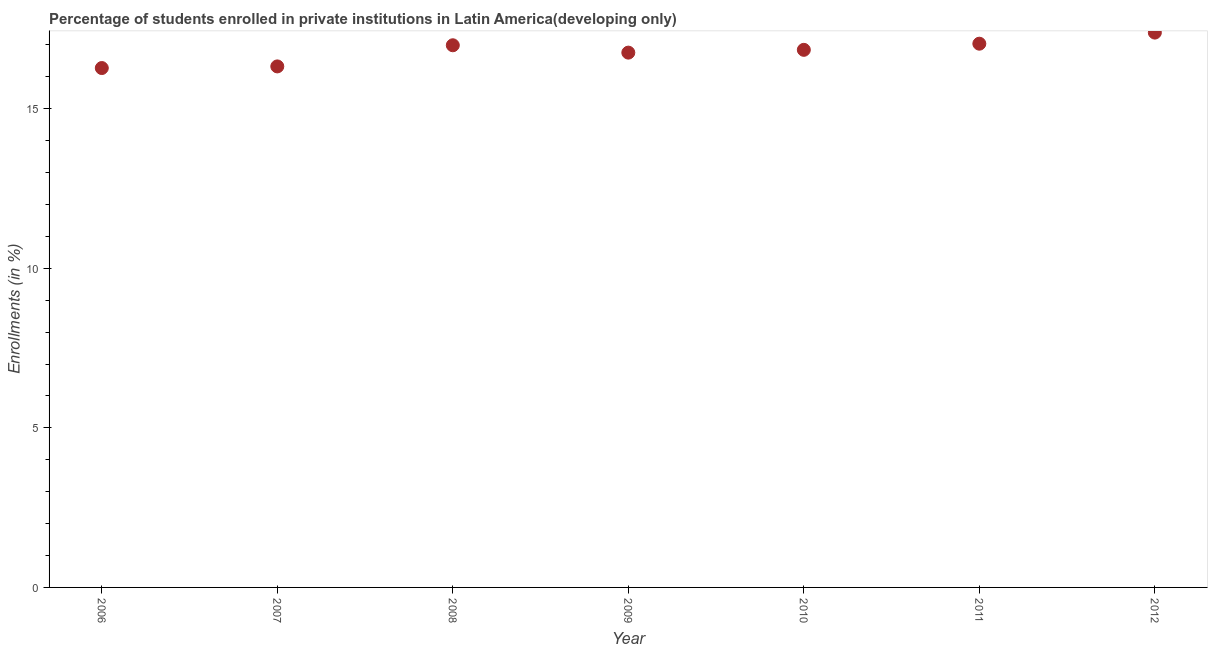What is the enrollments in private institutions in 2006?
Your response must be concise. 16.27. Across all years, what is the maximum enrollments in private institutions?
Your answer should be compact. 17.38. Across all years, what is the minimum enrollments in private institutions?
Offer a very short reply. 16.27. In which year was the enrollments in private institutions maximum?
Give a very brief answer. 2012. In which year was the enrollments in private institutions minimum?
Your response must be concise. 2006. What is the sum of the enrollments in private institutions?
Offer a very short reply. 117.6. What is the difference between the enrollments in private institutions in 2007 and 2008?
Make the answer very short. -0.66. What is the average enrollments in private institutions per year?
Provide a succinct answer. 16.8. What is the median enrollments in private institutions?
Provide a succinct answer. 16.84. In how many years, is the enrollments in private institutions greater than 12 %?
Your answer should be compact. 7. Do a majority of the years between 2010 and 2008 (inclusive) have enrollments in private institutions greater than 14 %?
Make the answer very short. No. What is the ratio of the enrollments in private institutions in 2009 to that in 2010?
Ensure brevity in your answer.  0.99. Is the difference between the enrollments in private institutions in 2008 and 2011 greater than the difference between any two years?
Your answer should be compact. No. What is the difference between the highest and the second highest enrollments in private institutions?
Your answer should be compact. 0.35. What is the difference between the highest and the lowest enrollments in private institutions?
Provide a succinct answer. 1.11. In how many years, is the enrollments in private institutions greater than the average enrollments in private institutions taken over all years?
Your answer should be very brief. 4. How many dotlines are there?
Ensure brevity in your answer.  1. Are the values on the major ticks of Y-axis written in scientific E-notation?
Keep it short and to the point. No. Does the graph contain any zero values?
Provide a succinct answer. No. What is the title of the graph?
Your answer should be very brief. Percentage of students enrolled in private institutions in Latin America(developing only). What is the label or title of the X-axis?
Ensure brevity in your answer.  Year. What is the label or title of the Y-axis?
Provide a succinct answer. Enrollments (in %). What is the Enrollments (in %) in 2006?
Your answer should be very brief. 16.27. What is the Enrollments (in %) in 2007?
Your answer should be very brief. 16.32. What is the Enrollments (in %) in 2008?
Your answer should be very brief. 16.99. What is the Enrollments (in %) in 2009?
Provide a succinct answer. 16.76. What is the Enrollments (in %) in 2010?
Offer a terse response. 16.84. What is the Enrollments (in %) in 2011?
Keep it short and to the point. 17.04. What is the Enrollments (in %) in 2012?
Keep it short and to the point. 17.38. What is the difference between the Enrollments (in %) in 2006 and 2007?
Keep it short and to the point. -0.05. What is the difference between the Enrollments (in %) in 2006 and 2008?
Offer a very short reply. -0.71. What is the difference between the Enrollments (in %) in 2006 and 2009?
Your answer should be compact. -0.48. What is the difference between the Enrollments (in %) in 2006 and 2010?
Make the answer very short. -0.57. What is the difference between the Enrollments (in %) in 2006 and 2011?
Give a very brief answer. -0.76. What is the difference between the Enrollments (in %) in 2006 and 2012?
Your response must be concise. -1.11. What is the difference between the Enrollments (in %) in 2007 and 2008?
Keep it short and to the point. -0.66. What is the difference between the Enrollments (in %) in 2007 and 2009?
Provide a succinct answer. -0.43. What is the difference between the Enrollments (in %) in 2007 and 2010?
Offer a terse response. -0.52. What is the difference between the Enrollments (in %) in 2007 and 2011?
Keep it short and to the point. -0.71. What is the difference between the Enrollments (in %) in 2007 and 2012?
Ensure brevity in your answer.  -1.06. What is the difference between the Enrollments (in %) in 2008 and 2009?
Give a very brief answer. 0.23. What is the difference between the Enrollments (in %) in 2008 and 2010?
Your answer should be very brief. 0.14. What is the difference between the Enrollments (in %) in 2008 and 2011?
Your answer should be very brief. -0.05. What is the difference between the Enrollments (in %) in 2008 and 2012?
Offer a terse response. -0.4. What is the difference between the Enrollments (in %) in 2009 and 2010?
Your response must be concise. -0.09. What is the difference between the Enrollments (in %) in 2009 and 2011?
Provide a short and direct response. -0.28. What is the difference between the Enrollments (in %) in 2009 and 2012?
Provide a short and direct response. -0.63. What is the difference between the Enrollments (in %) in 2010 and 2011?
Provide a succinct answer. -0.19. What is the difference between the Enrollments (in %) in 2010 and 2012?
Offer a terse response. -0.54. What is the difference between the Enrollments (in %) in 2011 and 2012?
Provide a short and direct response. -0.35. What is the ratio of the Enrollments (in %) in 2006 to that in 2007?
Your answer should be very brief. 1. What is the ratio of the Enrollments (in %) in 2006 to that in 2008?
Offer a terse response. 0.96. What is the ratio of the Enrollments (in %) in 2006 to that in 2010?
Your answer should be very brief. 0.97. What is the ratio of the Enrollments (in %) in 2006 to that in 2011?
Give a very brief answer. 0.95. What is the ratio of the Enrollments (in %) in 2006 to that in 2012?
Your response must be concise. 0.94. What is the ratio of the Enrollments (in %) in 2007 to that in 2008?
Your answer should be very brief. 0.96. What is the ratio of the Enrollments (in %) in 2007 to that in 2010?
Give a very brief answer. 0.97. What is the ratio of the Enrollments (in %) in 2007 to that in 2011?
Your answer should be very brief. 0.96. What is the ratio of the Enrollments (in %) in 2007 to that in 2012?
Offer a terse response. 0.94. What is the ratio of the Enrollments (in %) in 2008 to that in 2010?
Your answer should be very brief. 1.01. What is the ratio of the Enrollments (in %) in 2008 to that in 2012?
Provide a succinct answer. 0.98. What is the ratio of the Enrollments (in %) in 2009 to that in 2012?
Ensure brevity in your answer.  0.96. What is the ratio of the Enrollments (in %) in 2010 to that in 2012?
Ensure brevity in your answer.  0.97. 